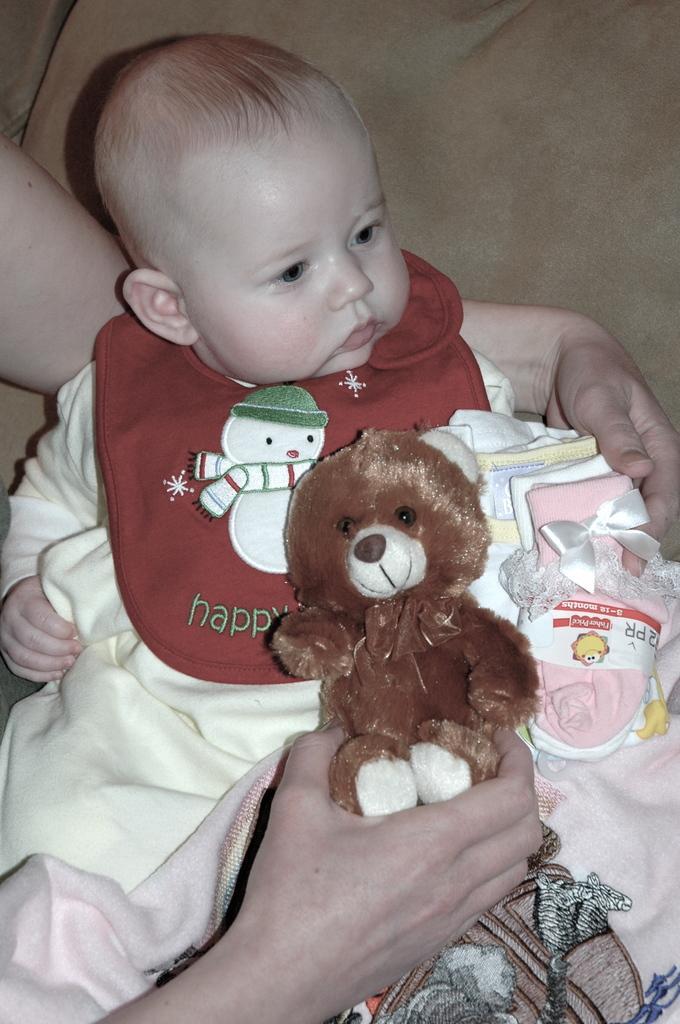Can you describe this image briefly? Here I can see a person is carrying a baby and holding a toy. The baby is looking at the right side. 